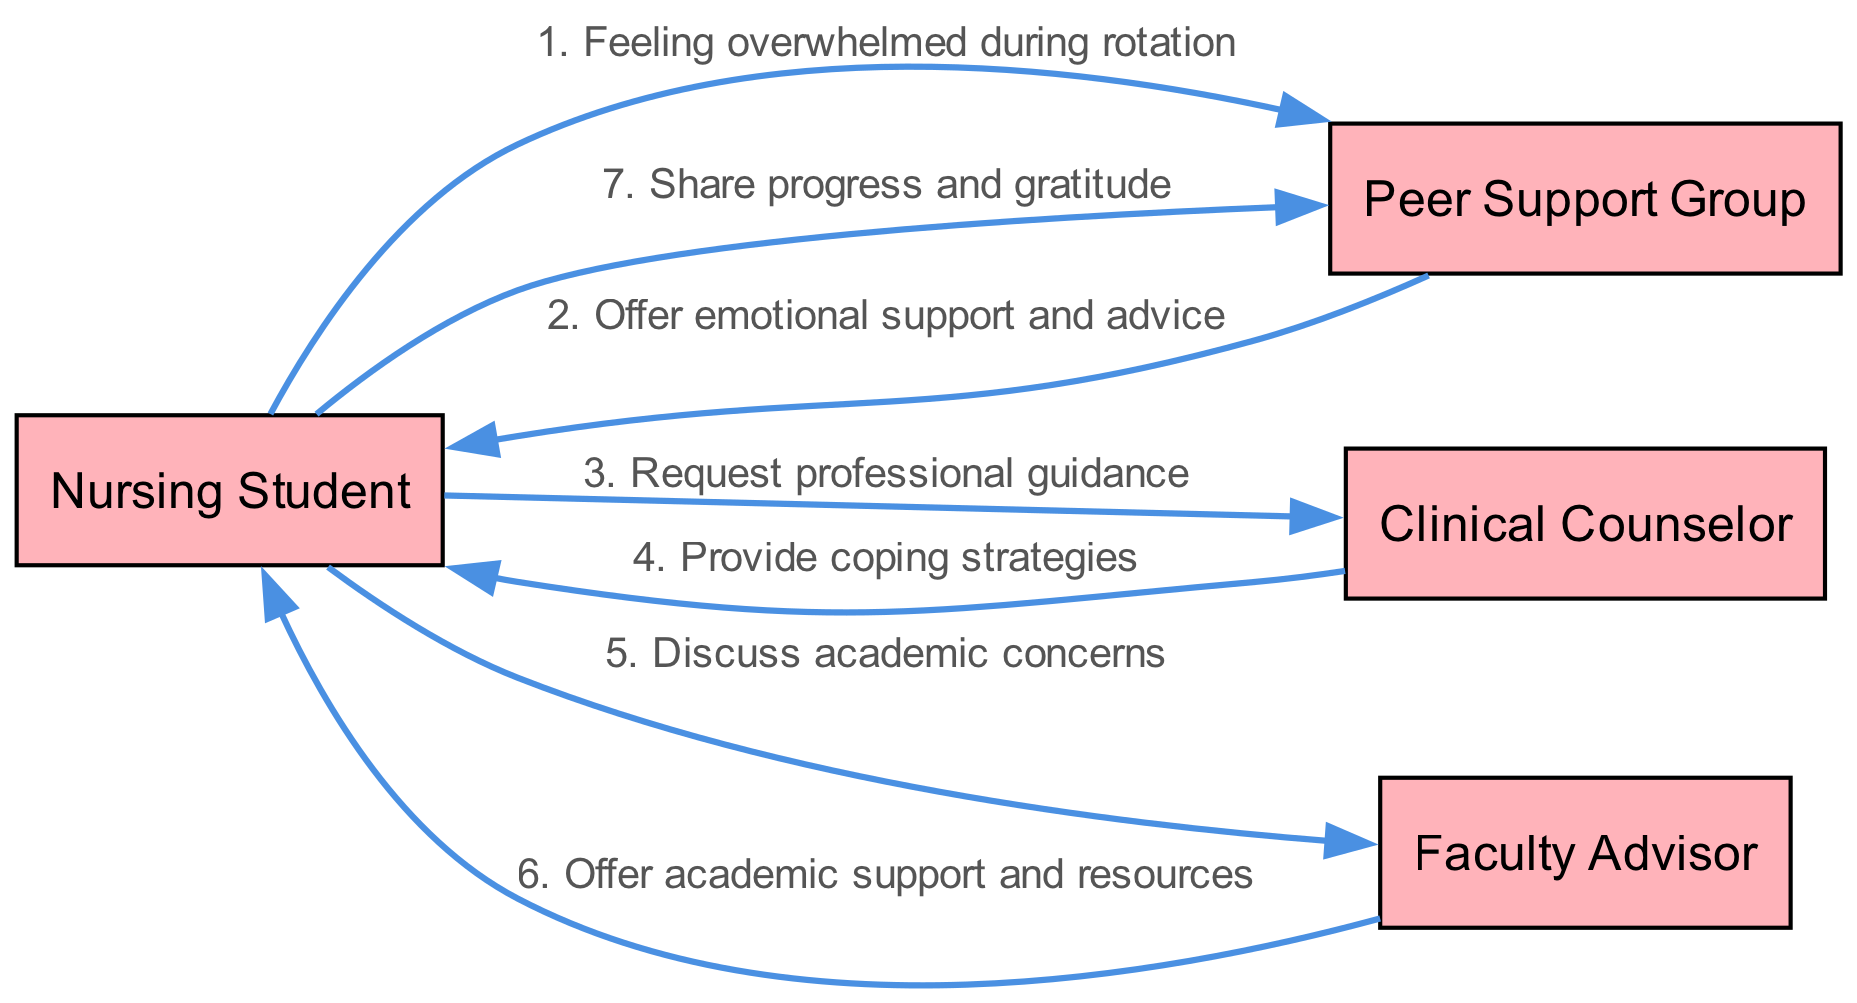What are the actors involved in the diagram? The actors listed in the diagram are "Nursing Student," "Peer Support Group," "Clinical Counselor," and "Faculty Advisor." These are the roles that interact within the emotional support system depicted.
Answer: Nursing Student, Peer Support Group, Clinical Counselor, Faculty Advisor How many messages are exchanged between the actors? There are a total of six messages exchanged among the actors in the diagram. Each message represents a distinct interaction or communication that takes place within the emotional support system.
Answer: 6 Who does the Nursing Student communicate with first? The first communication from the Nursing Student is directed to the Peer Support Group, where they express feeling overwhelmed during the clinical rotation. This is the initial step in seeking support.
Answer: Peer Support Group What support does the Clinical Counselor provide to the Nursing Student? The Clinical Counselor provides coping strategies to the Nursing Student. This interaction demonstrates the professional guidance that the student sought in their moment of stress.
Answer: Coping strategies Which actor does the Nursing Student thank after sharing their progress? After sharing their progress and gratitude, the Nursing Student is communicating back to the Peer Support Group. This shows the feedback loop in their interactions after receiving support.
Answer: Peer Support Group What is the relationship between "Nursing Student" and "Faculty Advisor"? The Nursing Student discusses academic concerns with the Faculty Advisor, who then offers academic support and resources. This illustrates a supportive relationship in an academic context.
Answer: Academic concerns Which message comes last in the sequence of communications? The last message in the sequence of communications is the Nursing Student sharing progress and gratitude with the Peer Support Group, highlighting the importance of expressing appreciation in support systems.
Answer: Share progress and gratitude How many unique interactions does the Peer Support Group have in the diagram? The Peer Support Group has three unique interactions in the diagram: first, they respond to the Nursing Student with support, then they maintain contact by receiving updates after the Nursing Student shares their progress.
Answer: 3 